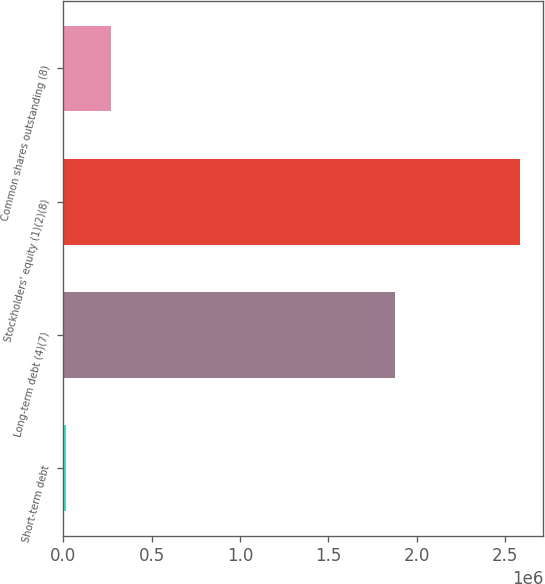Convert chart to OTSL. <chart><loc_0><loc_0><loc_500><loc_500><bar_chart><fcel>Short-term debt<fcel>Long-term debt (4)(7)<fcel>Stockholders' equity (1)(2)(8)<fcel>Common shares outstanding (8)<nl><fcel>14856<fcel>1.87662e+06<fcel>2.58496e+06<fcel>271866<nl></chart> 